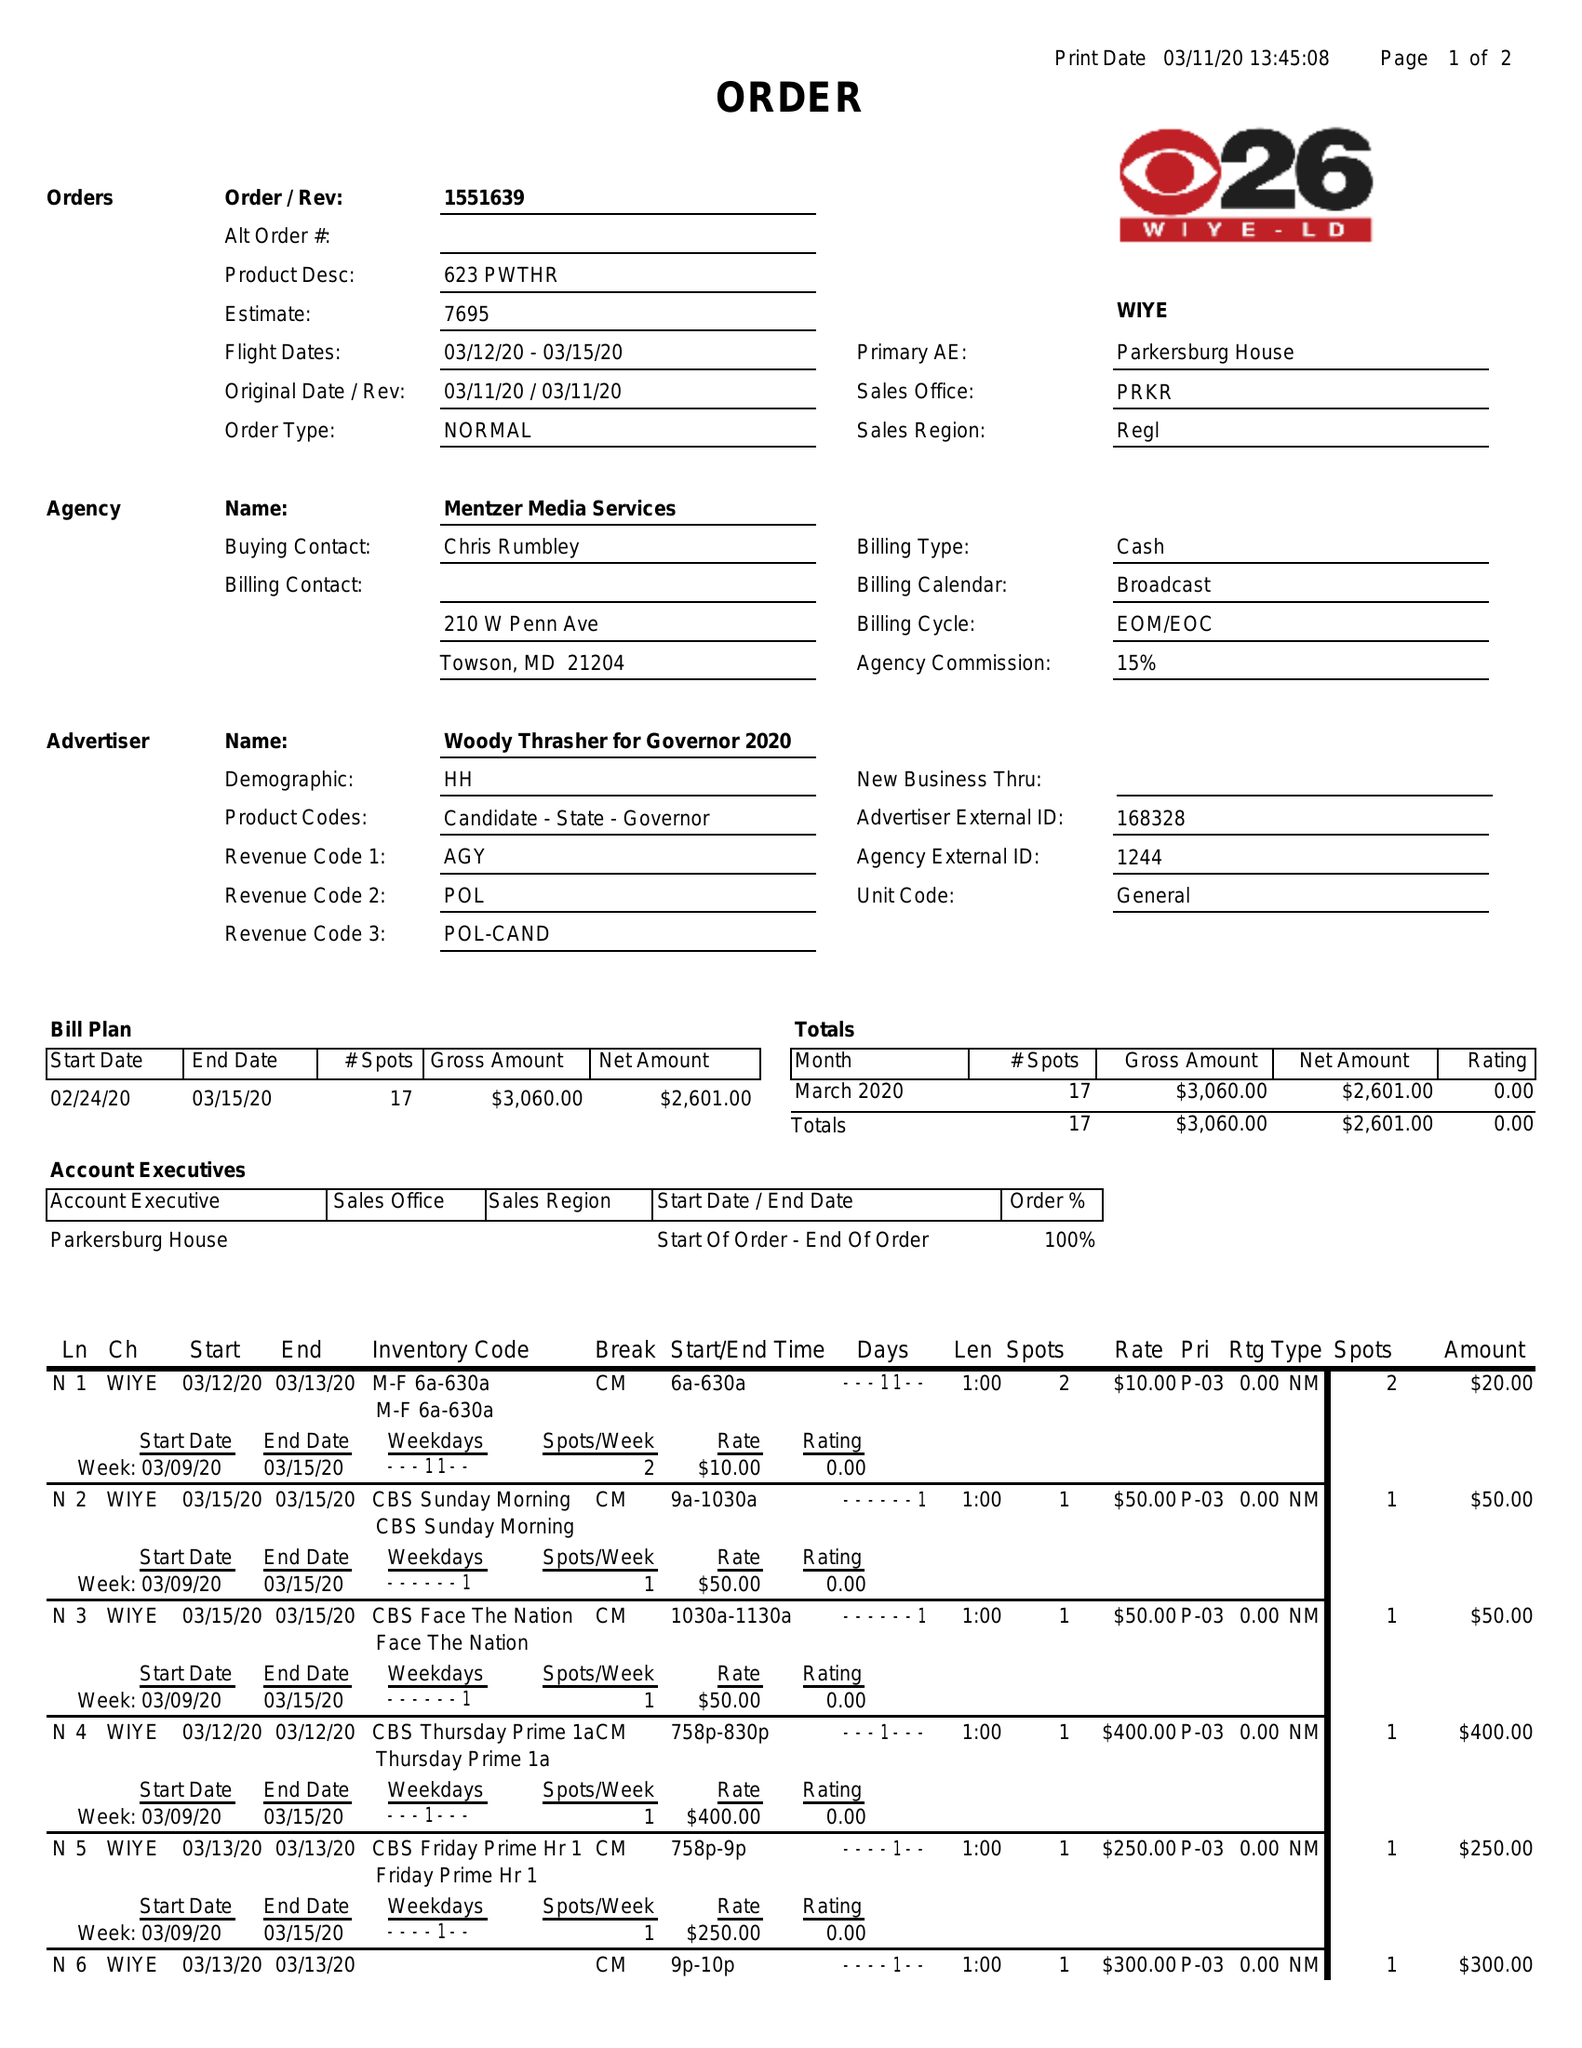What is the value for the contract_num?
Answer the question using a single word or phrase. 1551639 